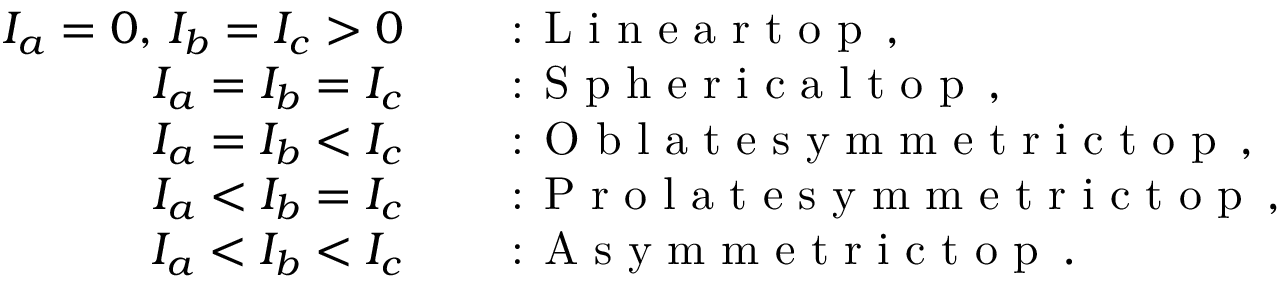<formula> <loc_0><loc_0><loc_500><loc_500>\begin{array} { r l } { I _ { a } = 0 , \, I _ { b } = I _ { c } > 0 \quad } & { \colon L i n e a r t o p \, , } \\ { I _ { a } = I _ { b } = I _ { c } \quad } & { \colon S p h e r i c a l t o p \, , } \\ { I _ { a } = I _ { b } < I _ { c } \quad } & { \colon O b l a t e s y m m e t r i c t o p \, , } \\ { I _ { a } < I _ { b } = I _ { c } \quad } & { \colon P r o l a t e s y m m e t r i c t o p \, , } \\ { I _ { a } < I _ { b } < I _ { c } \quad } & { \colon A s y m m e t r i c t o p \, . } \end{array}</formula> 